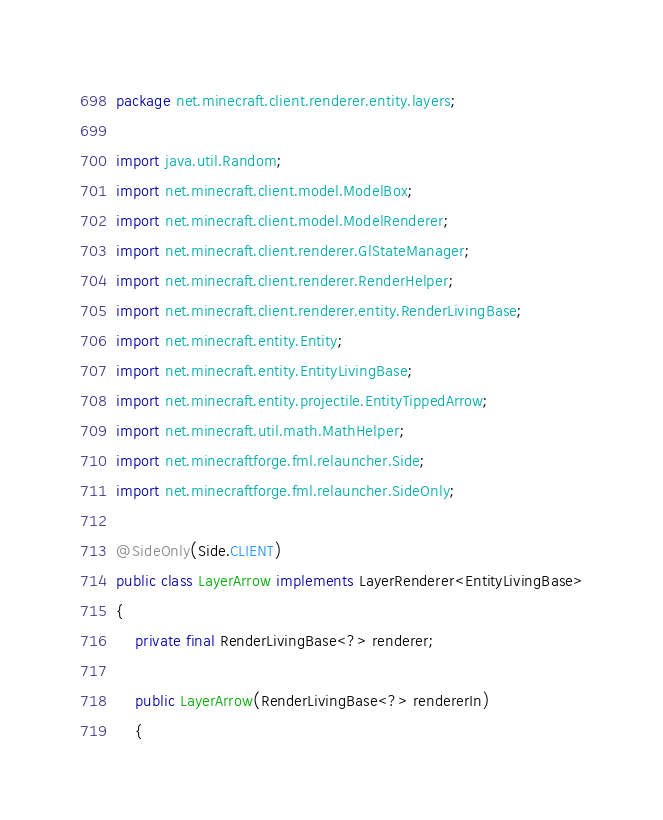Convert code to text. <code><loc_0><loc_0><loc_500><loc_500><_Java_>package net.minecraft.client.renderer.entity.layers;

import java.util.Random;
import net.minecraft.client.model.ModelBox;
import net.minecraft.client.model.ModelRenderer;
import net.minecraft.client.renderer.GlStateManager;
import net.minecraft.client.renderer.RenderHelper;
import net.minecraft.client.renderer.entity.RenderLivingBase;
import net.minecraft.entity.Entity;
import net.minecraft.entity.EntityLivingBase;
import net.minecraft.entity.projectile.EntityTippedArrow;
import net.minecraft.util.math.MathHelper;
import net.minecraftforge.fml.relauncher.Side;
import net.minecraftforge.fml.relauncher.SideOnly;

@SideOnly(Side.CLIENT)
public class LayerArrow implements LayerRenderer<EntityLivingBase>
{
    private final RenderLivingBase<?> renderer;

    public LayerArrow(RenderLivingBase<?> rendererIn)
    {</code> 